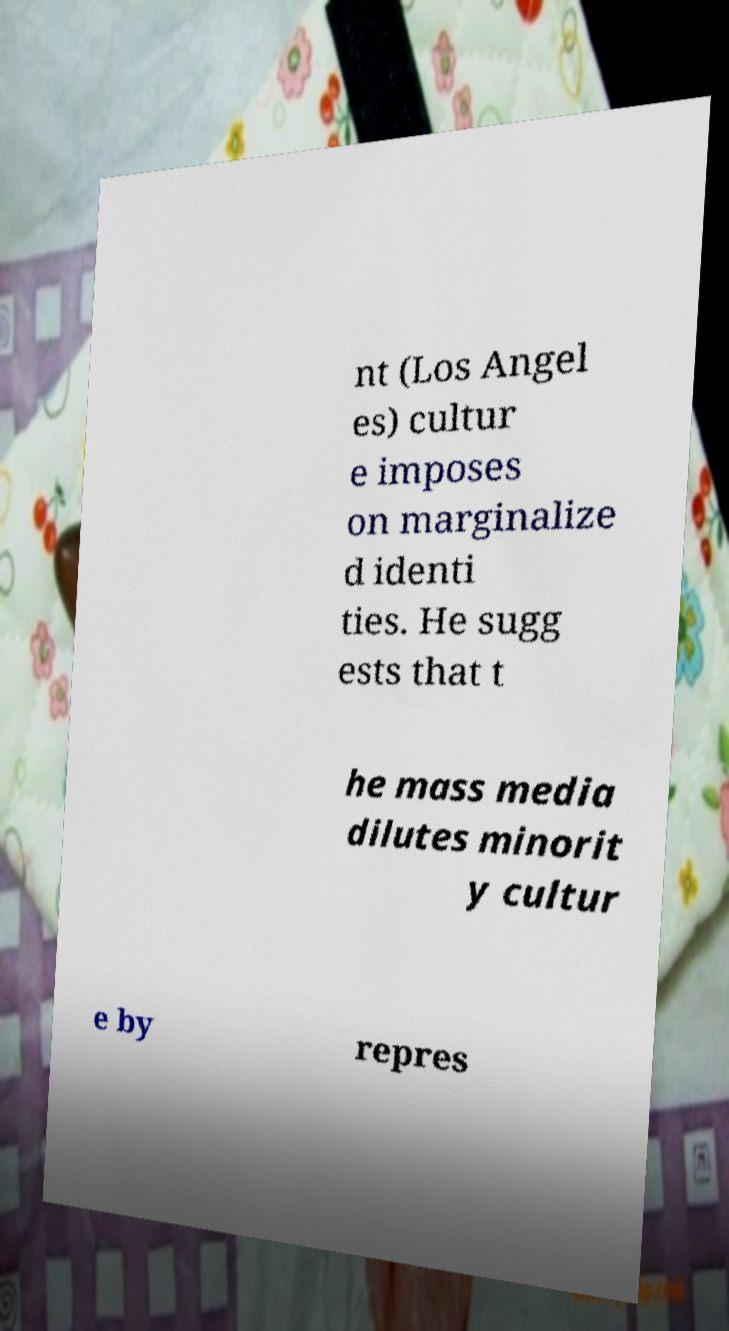Can you read and provide the text displayed in the image?This photo seems to have some interesting text. Can you extract and type it out for me? nt (Los Angel es) cultur e imposes on marginalize d identi ties. He sugg ests that t he mass media dilutes minorit y cultur e by repres 